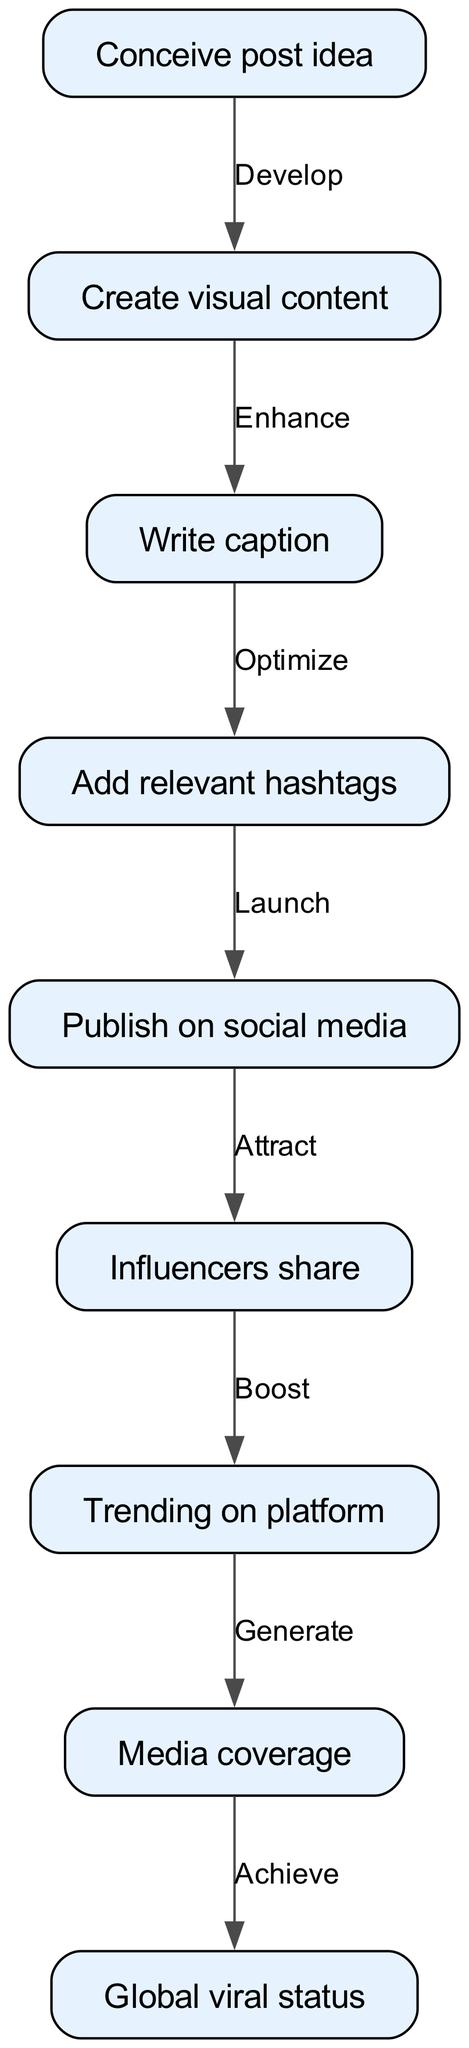What is the first step in the lifecycle of a viral social media post? The first step, indicated by the initial node in the diagram, is "Conceive post idea." This is directly shown as the starting point of the flow.
Answer: Conceive post idea How many total nodes are present in the diagram? By counting each unique node in the diagram, we find 9 nodes total, including all steps from creation to viral status.
Answer: 9 What action follows "Write caption"? The diagram illustrates that after "Write caption," the next action is "Add relevant hashtags," showing a direct connection between these two nodes.
Answer: Add relevant hashtags Which node indicates the status of being shared by influencers? The node that represents influencers sharing the post is "Influencers share," as it is directly highlighted in the flowchart preceding the trending and media coverage stages.
Answer: Influencers share What is the relationship between "Trending on platform" and "Media coverage"? The diagram specifies that "Trending on platform" leads to "Media coverage," meaning that achieving trending status generates media attention as the next logical step.
Answer: Generate How many edges are present in the diagram? The diagram contains 8 edges, each representing a transition or action from one node to another in the flow of a viral post's lifecycle.
Answer: 8 What happens after "Media coverage"? Following "Media coverage," the next step in the flowchart is to "Achieve global viral status," indicating that media attention can lead to widespread recognition.
Answer: Achieve global viral status What is the final outcome of the process illustrated in the diagram? The end node indicates that the final outcome of the entire lifecycle is "Global viral status," representing the ultimate goal of the entire sequence.
Answer: Global viral status Which step is directly before "Trending on platform"? According to the diagram, the step that comes directly before "Trending on platform" is "Influencers share," demonstrating the influence of key users' interactions on its popularity.
Answer: Influencers share 